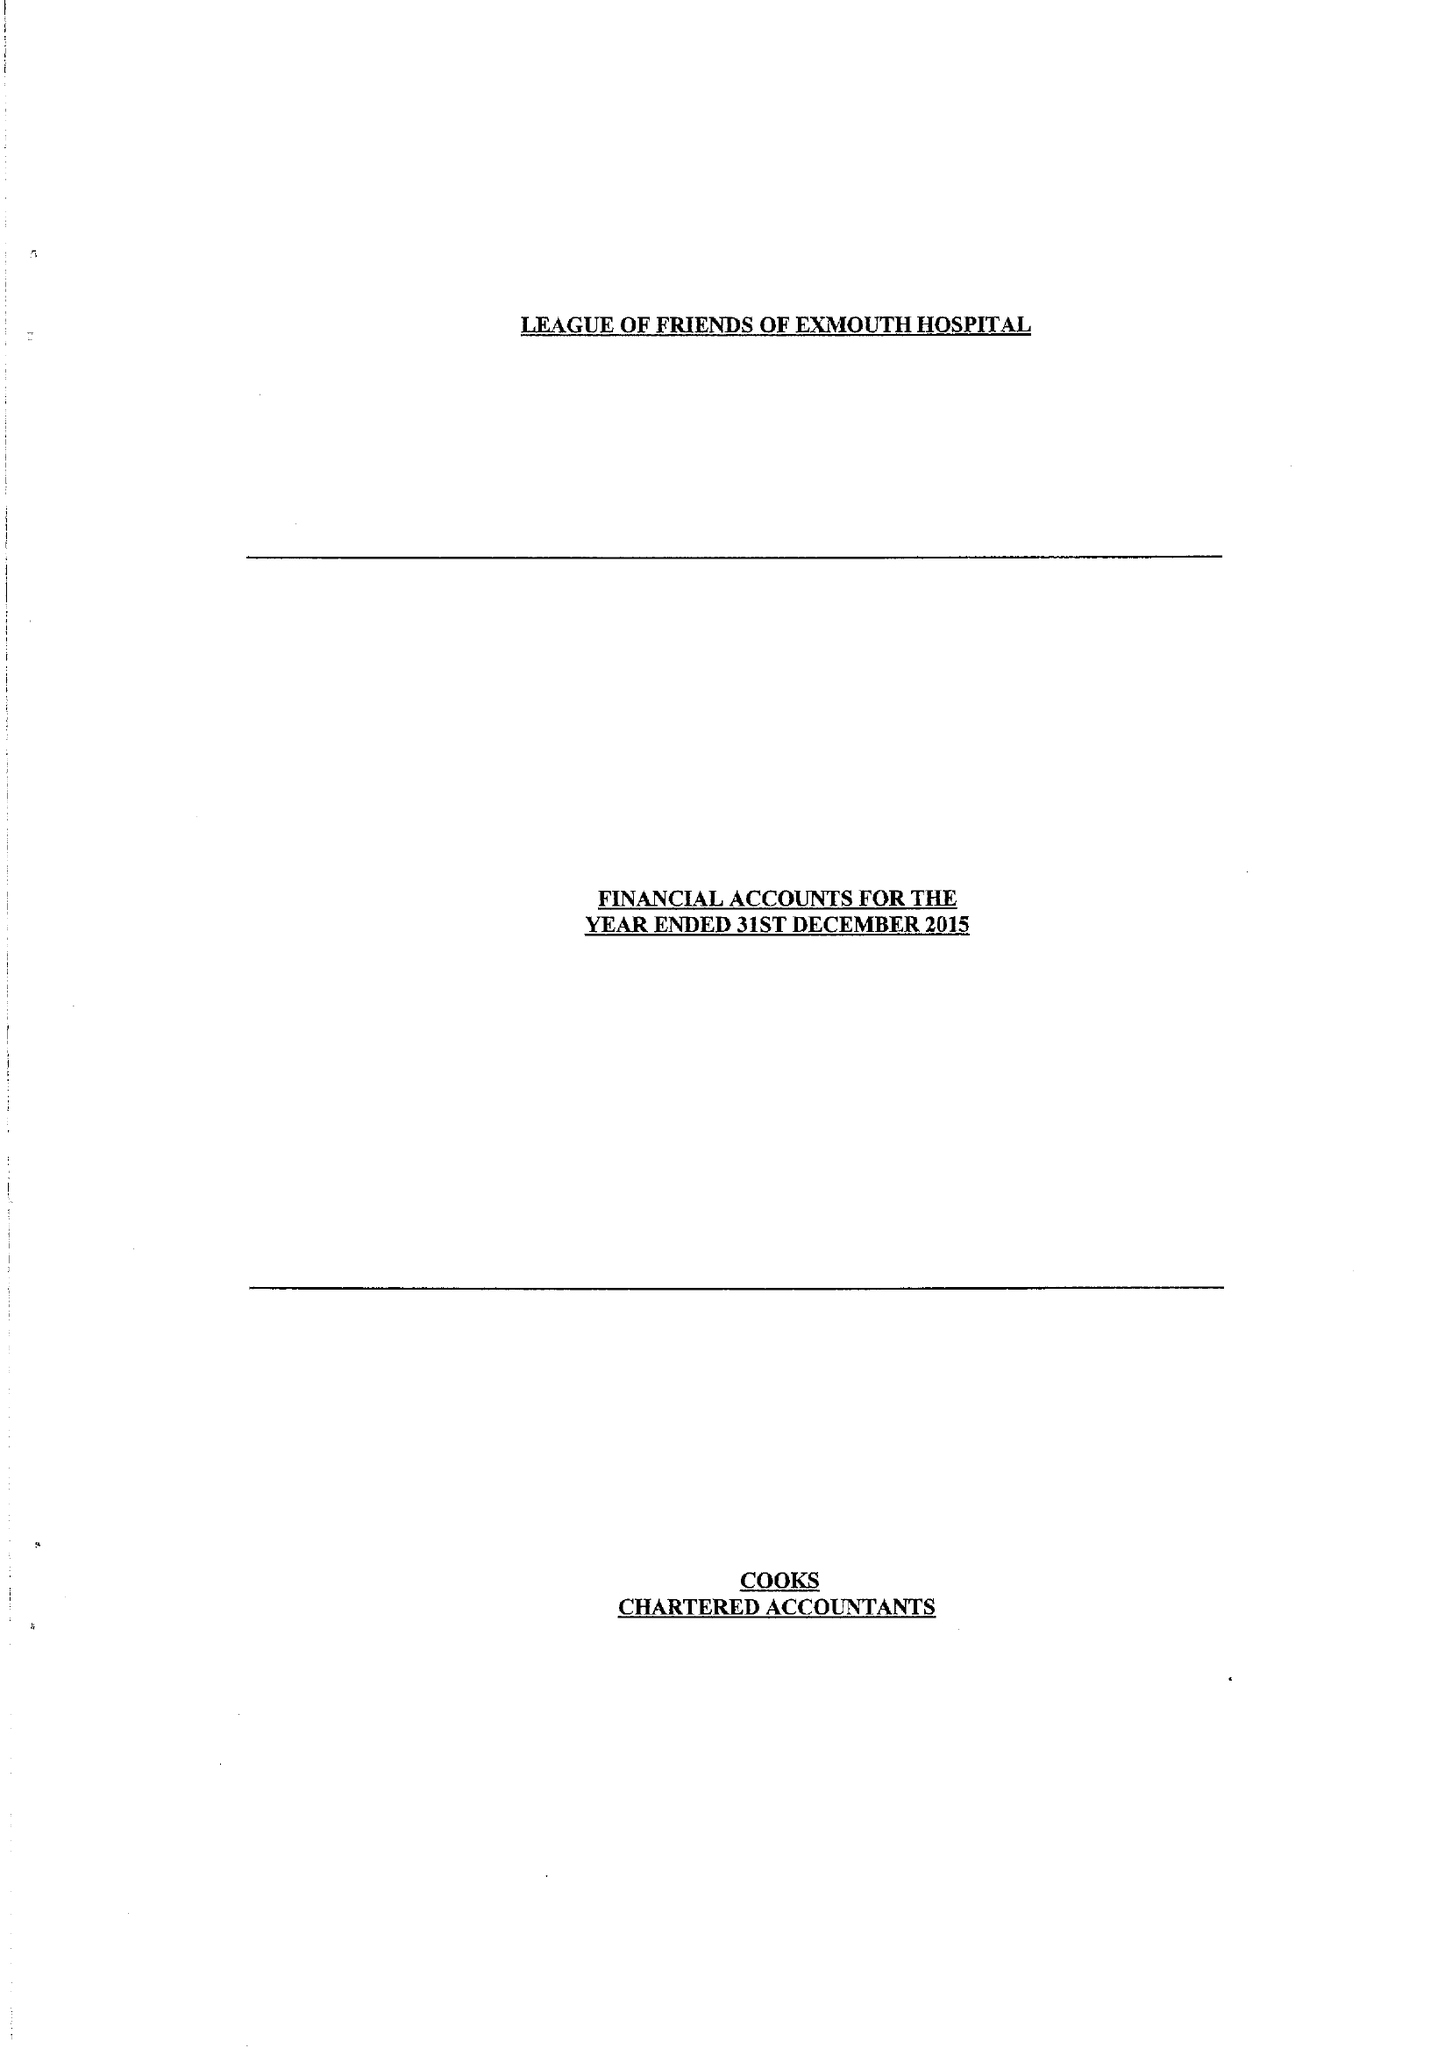What is the value for the spending_annually_in_british_pounds?
Answer the question using a single word or phrase. 54786.00 